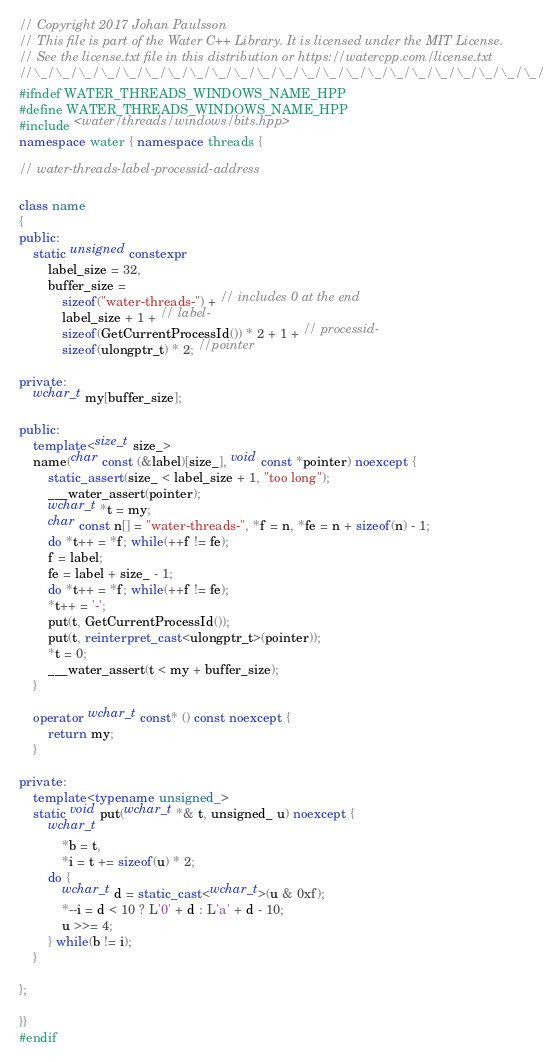Convert code to text. <code><loc_0><loc_0><loc_500><loc_500><_C++_>// Copyright 2017 Johan Paulsson
// This file is part of the Water C++ Library. It is licensed under the MIT License.
// See the license.txt file in this distribution or https://watercpp.com/license.txt
//\_/\_/\_/\_/\_/\_/\_/\_/\_/\_/\_/\_/\_/\_/\_/\_/\_/\_/\_/\_/\_/\_/\_/\_/\_/\_/\_/\_
#ifndef WATER_THREADS_WINDOWS_NAME_HPP
#define WATER_THREADS_WINDOWS_NAME_HPP
#include <water/threads/windows/bits.hpp>
namespace water { namespace threads {

// water-threads-label-processid-address

class name
{
public:
    static unsigned constexpr
        label_size = 32,
        buffer_size =
            sizeof("water-threads-") + // includes 0 at the end
            label_size + 1 + // label-
            sizeof(GetCurrentProcessId()) * 2 + 1 + // processid-
            sizeof(ulongptr_t) * 2; //pointer

private:
    wchar_t my[buffer_size];

public:
    template<size_t size_>
    name(char const (&label)[size_], void const *pointer) noexcept {
        static_assert(size_ < label_size + 1, "too long");
        ___water_assert(pointer);
        wchar_t *t = my;
        char const n[] = "water-threads-", *f = n, *fe = n + sizeof(n) - 1;
        do *t++ = *f; while(++f != fe);
        f = label;
        fe = label + size_ - 1;
        do *t++ = *f; while(++f != fe);
        *t++ = '-';
        put(t, GetCurrentProcessId());
        put(t, reinterpret_cast<ulongptr_t>(pointer));
        *t = 0;
        ___water_assert(t < my + buffer_size);
    }

    operator wchar_t const* () const noexcept {
        return my;
    }

private:
    template<typename unsigned_>
    static void put(wchar_t *& t, unsigned_ u) noexcept {
        wchar_t
            *b = t,
            *i = t += sizeof(u) * 2;
        do {
            wchar_t d = static_cast<wchar_t>(u & 0xf);
            *--i = d < 10 ? L'0' + d : L'a' + d - 10;
            u >>= 4;
        } while(b != i);
    }
    
};

}}
#endif
</code> 